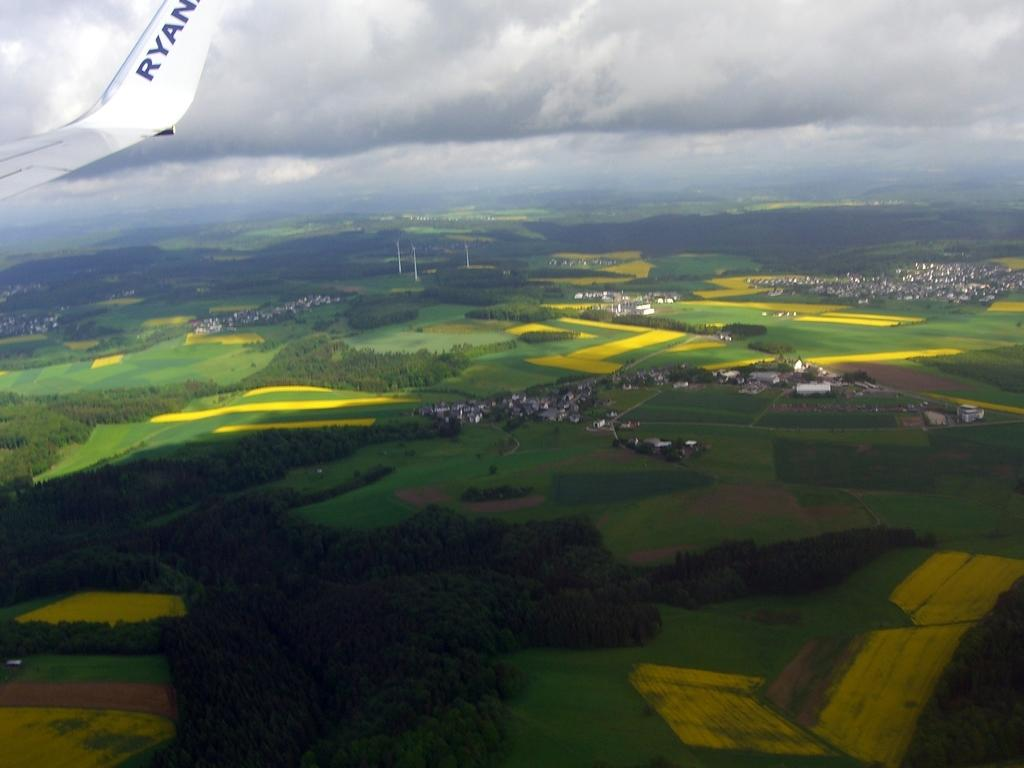What type of view is depicted in the image? The image is an aerial view. What natural elements can be seen in the image? There are trees in the image. What man-made structures are visible in the image? There is a city visible in the image. What type of terrain is present in the image? There is land in the image. What are the poles used for in the image? The purpose of the poles is not specified in the image, but they could be used for various purposes such as power lines or signage. What part of the plane can be seen in the image? The wing of a plane is visible in the top left corner of the image. What is visible in the sky in the image? The sky is visible in the image, and there is a cloud present. What type of music can be heard playing in the image? There is no music present in the image; it is a still photograph. What type of rice is being grown in the image? There is no rice visible in the image; it features an aerial view of a city and surrounding land. 